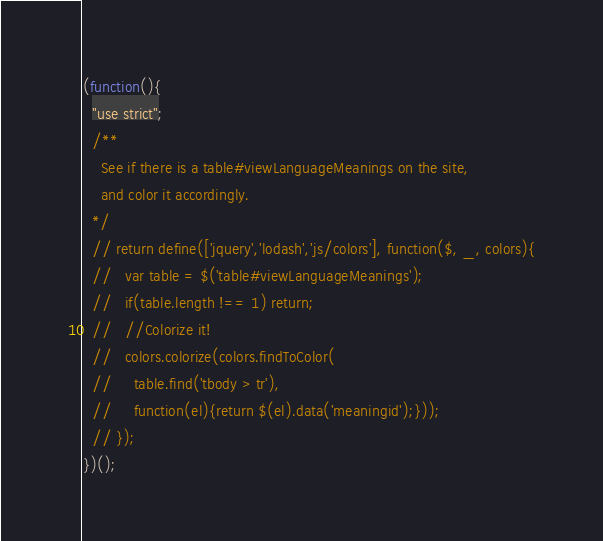<code> <loc_0><loc_0><loc_500><loc_500><_JavaScript_>(function(){
  "use strict";
  /**
    See if there is a table#viewLanguageMeanings on the site,
    and color it accordingly.
  */
  // return define(['jquery','lodash','js/colors'], function($, _, colors){
  //   var table = $('table#viewLanguageMeanings');
  //   if(table.length !== 1) return;
  //   //Colorize it!
  //   colors.colorize(colors.findToColor(
  //     table.find('tbody > tr'),
  //     function(el){return $(el).data('meaningid');}));
  // });
})();
</code> 